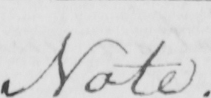Transcribe the text shown in this historical manuscript line. Note . 